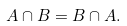<formula> <loc_0><loc_0><loc_500><loc_500>A \cap B = B \cap A .</formula> 